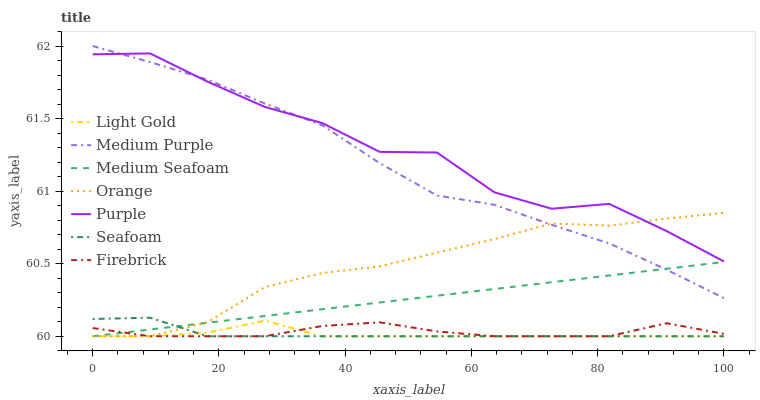Does Firebrick have the minimum area under the curve?
Answer yes or no. No. Does Firebrick have the maximum area under the curve?
Answer yes or no. No. Is Firebrick the smoothest?
Answer yes or no. No. Is Firebrick the roughest?
Answer yes or no. No. Does Medium Purple have the lowest value?
Answer yes or no. No. Does Seafoam have the highest value?
Answer yes or no. No. Is Seafoam less than Medium Purple?
Answer yes or no. Yes. Is Medium Purple greater than Seafoam?
Answer yes or no. Yes. Does Seafoam intersect Medium Purple?
Answer yes or no. No. 